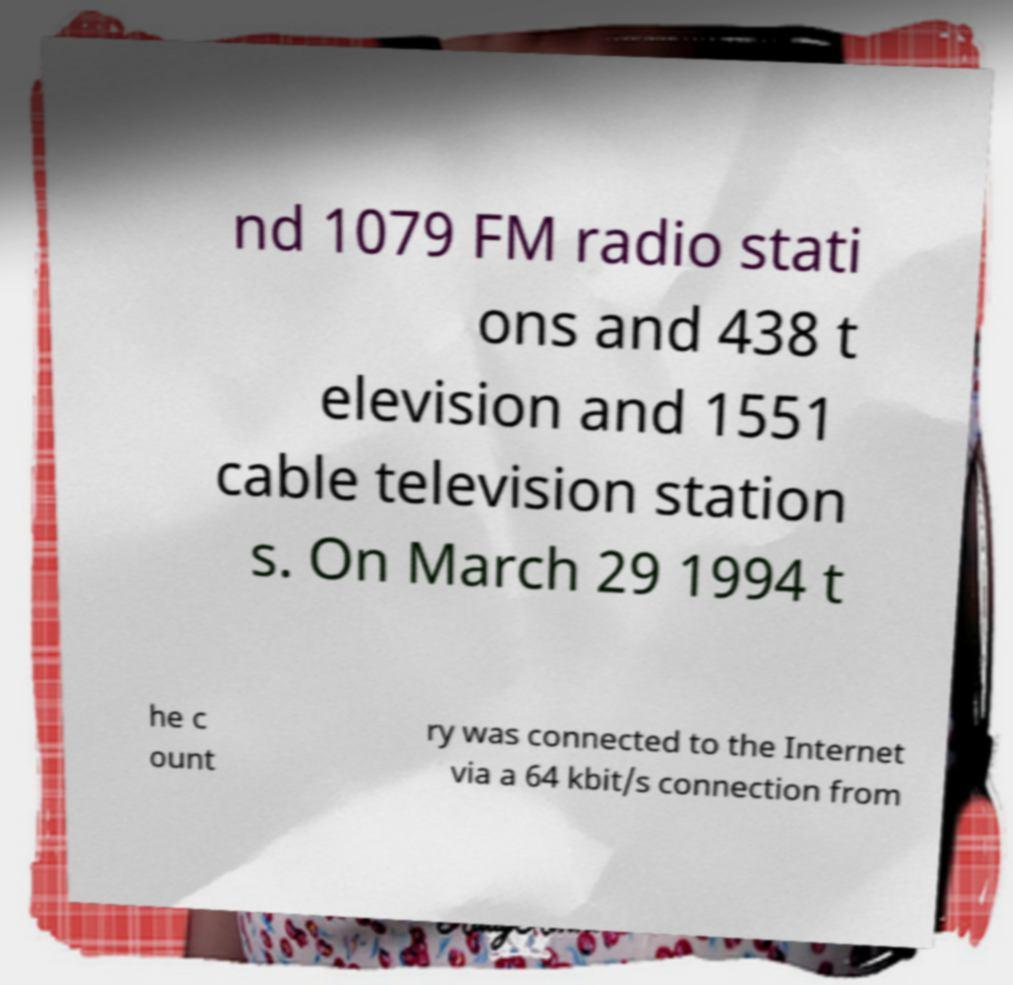There's text embedded in this image that I need extracted. Can you transcribe it verbatim? nd 1079 FM radio stati ons and 438 t elevision and 1551 cable television station s. On March 29 1994 t he c ount ry was connected to the Internet via a 64 kbit/s connection from 